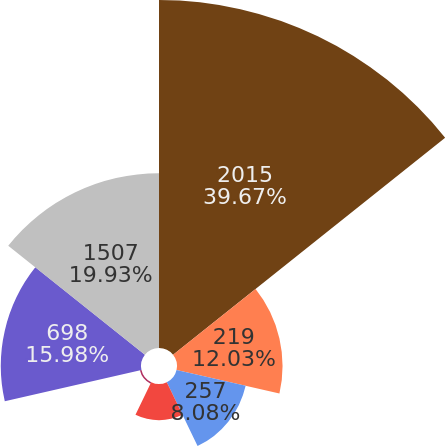Convert chart. <chart><loc_0><loc_0><loc_500><loc_500><pie_chart><fcel>2015<fcel>219<fcel>257<fcel>221<fcel>112<fcel>698<fcel>1507<nl><fcel>39.67%<fcel>12.03%<fcel>8.08%<fcel>4.13%<fcel>0.18%<fcel>15.98%<fcel>19.93%<nl></chart> 